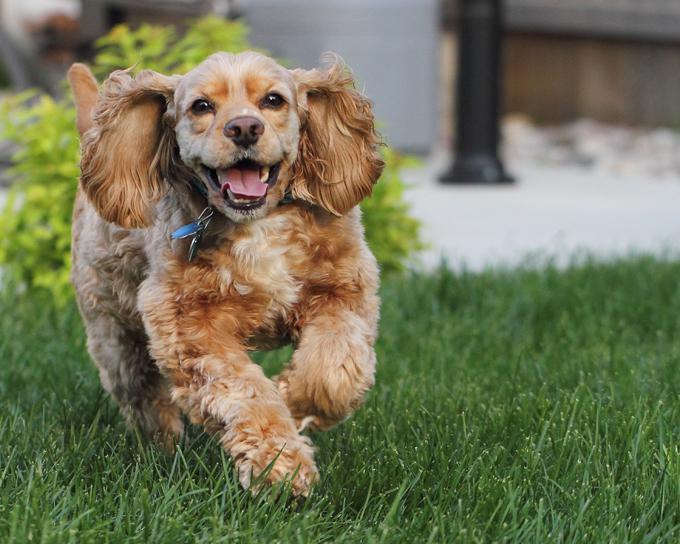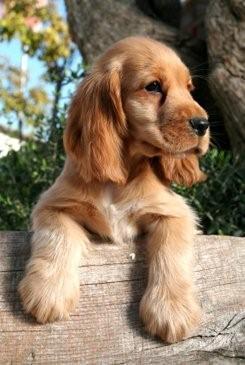The first image is the image on the left, the second image is the image on the right. Examine the images to the left and right. Is the description "An upright cocket spaniel is outdoors and has its tongue extended but not licking its nose." accurate? Answer yes or no. Yes. The first image is the image on the left, the second image is the image on the right. Evaluate the accuracy of this statement regarding the images: "A single dog is on grass". Is it true? Answer yes or no. Yes. 